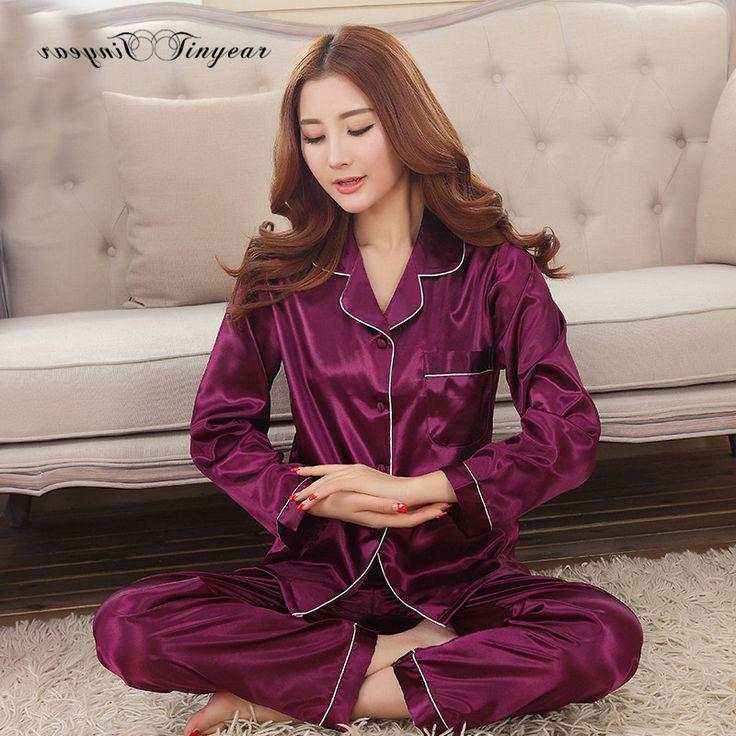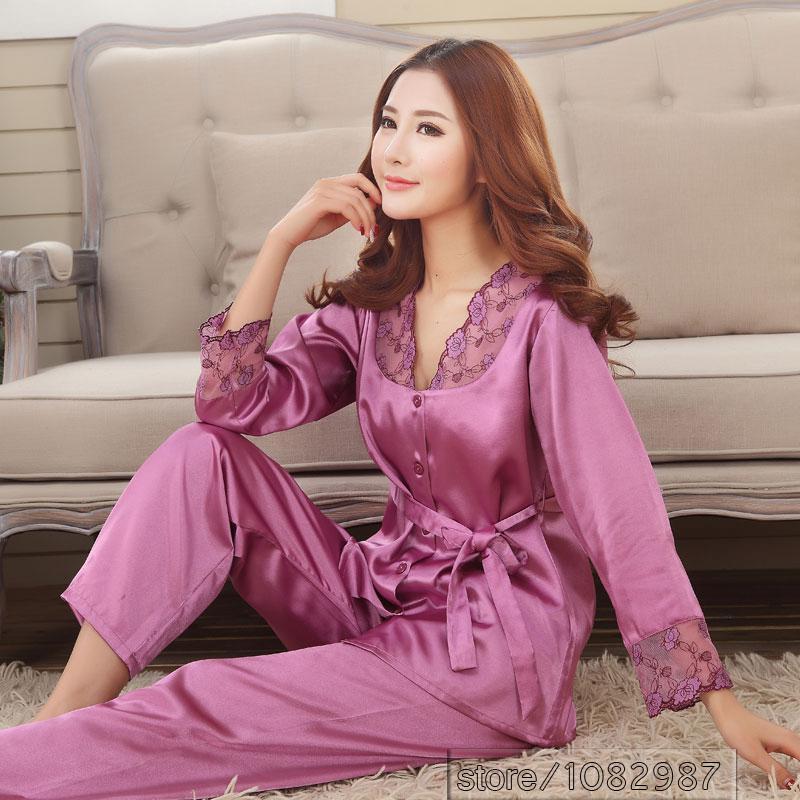The first image is the image on the left, the second image is the image on the right. Considering the images on both sides, is "A solid colored pajama set has long pants paired with a long sleeved shirt with contrasting piping on the shirt cuffs and collar." valid? Answer yes or no. Yes. The first image is the image on the left, the second image is the image on the right. For the images shown, is this caption "One model is wearing purple pajamas and sitting cross-legged on the floor in front of a tufted sofa." true? Answer yes or no. Yes. 